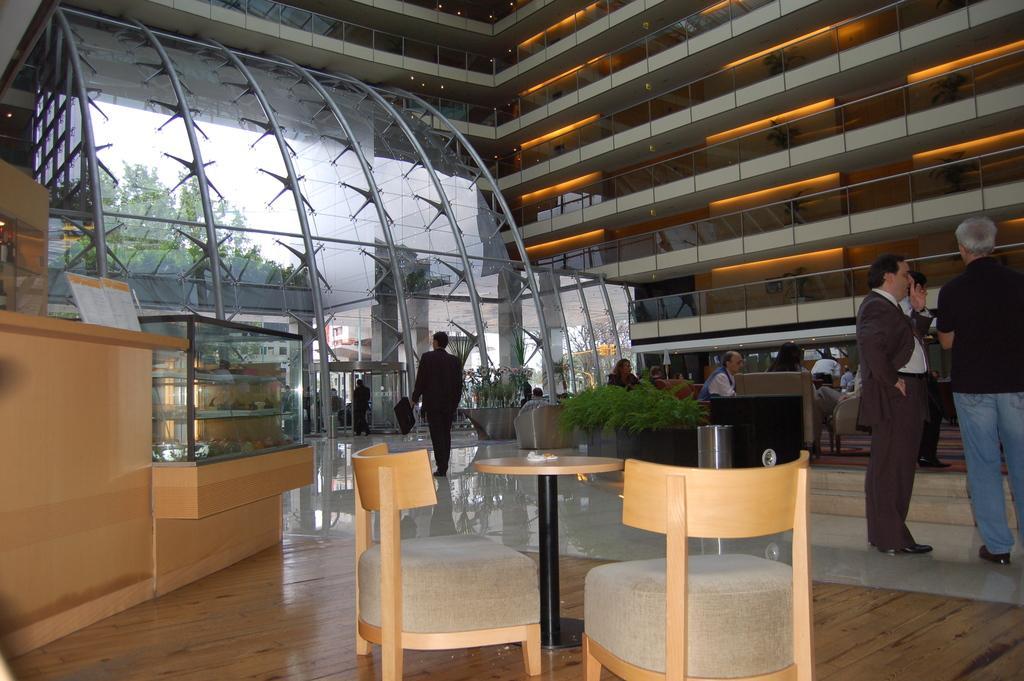Describe this image in one or two sentences. In this image few persons are standing on the floor. There are few plants in the pots. Left side there is a desk having a board on it. Bottom of the image there is a table and two chairs are on the floor. Right side there are few balconies. Left side there is a glass wall. From it few trees and buildings are visible. 